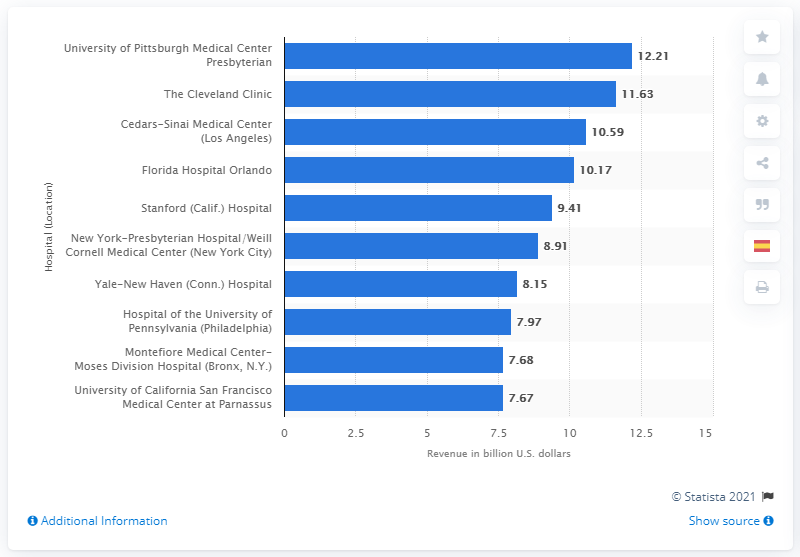Draw attention to some important aspects in this diagram. In 2013, the gross revenue of Cedars-Sinai Medical Center was approximately $10.59 billion. 